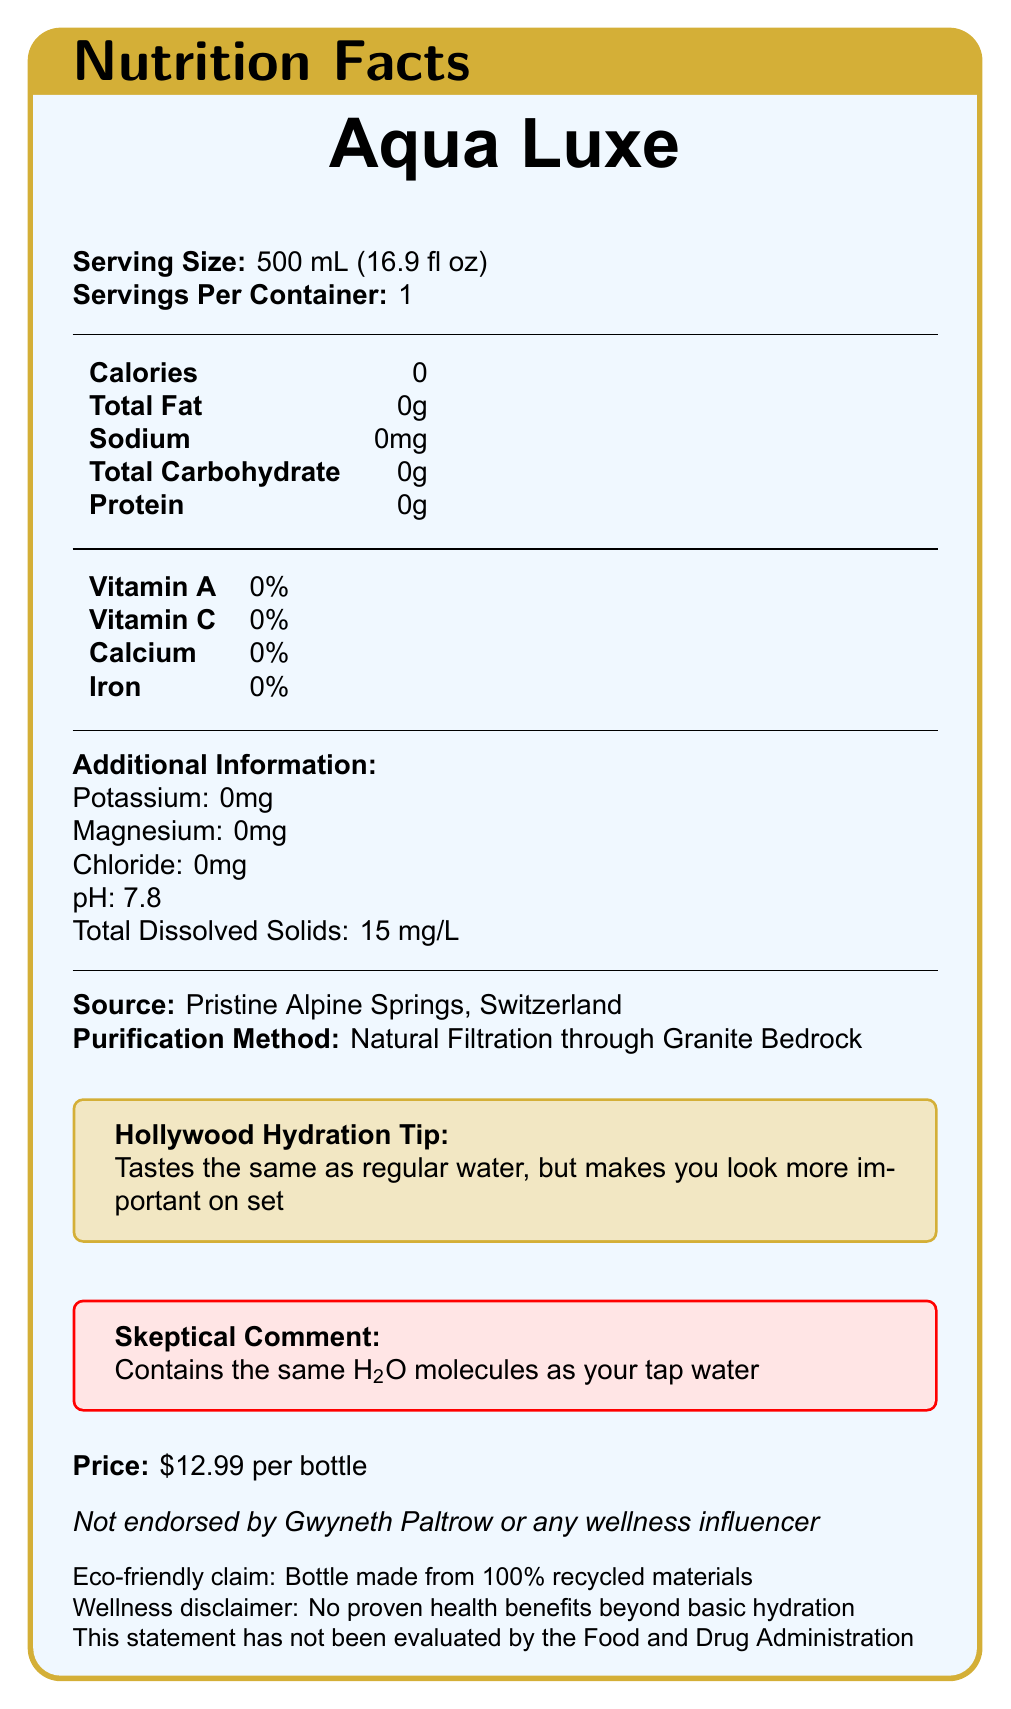what is the serving size for Aqua Luxe? The serving size is stated at the top of the document as 500 mL (16.9 fl oz).
Answer: 500 mL (16.9 fl oz) how much sodium is in Aqua Luxe? The document clearly lists sodium content as 0 mg.
Answer: 0 mg what is the source of the water? The source of the water is mentioned under "Additional Information" in the document.
Answer: Pristine Alpine Springs, Switzerland what is the price of a bottle of Aqua Luxe? The price is listed towards the end of the document as $12.99 per bottle.
Answer: $12.99 per bottle what is the pH level of Aqua Luxe? The pH level is included in the "Additional Information" section and is listed as 7.8.
Answer: 7.8 which vitamins are present in Aqua Luxe? A. Vitamin A and Vitamin C B. Vitamin A C. Vitamin C D. None The document states that both Vitamin A and Vitamin C are present at 0%, indicating the absence of these vitamins in the water.
Answer: D what purification method is used for Aqua Luxe? A. Reverse Osmosis B. Distillation C. Natural Filtration through Granite Bedrock D. Carbon Filtration The purification method is mentioned as "Natural Filtration through Granite Bedrock" in the document.
Answer: C does Aqua Luxe have any eco-friendly claims? The document states "Bottle made from 100% recycled materials" indicating an eco-friendly claim.
Answer: Yes is Aqua Luxe endorsed by Gwyneth Paltrow or any wellness influencer? The document specifically mentions that it is "Not endorsed by Gwyneth Paltrow or any wellness influencer."
Answer: No summarize the main idea of the document. The summary covers the key points in the document, including its minimal nutritional value, source, purification method, price, celebrity endorsement disclaimer, and eco-friendly claim.
Answer: Aqua Luxe is a high-end bottled water brand with minimal nutritional value but is advertised as sourced from pristine Alpine springs and purified naturally. It is marketed with a Hollywood flair and an eco-friendly claim, yet it maintains a skeptical stance about additional health benefits. what is the magnesium content in Aqua Luxe? The "Additional Information" section lists magnesium content as 0 mg.
Answer: 0 mg can we determine if Aqua Luxe improves hydration more than regular water? The document states "No proven health benefits beyond basic hydration," implying there is no evidence Aqua Luxe improves hydration more than regular water.
Answer: Not enough information what is the dissolved solids content of Aqua Luxe? The "Additional Information" section lists the total dissolved solids as 15 mg/L.
Answer: 15 mg/L which nutrients are labeled at 0% DV (Daily Value)? The document lists that Vitamin A, Vitamin C, Calcium, and Iron all have 0% Daily Value.
Answer: Vitamin A, Vitamin C, Calcium, Iron is Aqua Luxe FDA evaluated? The document includes a statement that "This statement has not been evaluated by the Food and Drug Administration," clarifying it is not FDA evaluated.
Answer: No 